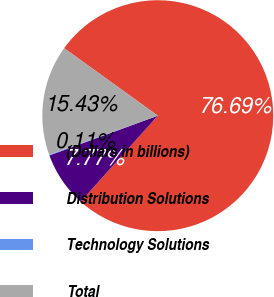Convert chart to OTSL. <chart><loc_0><loc_0><loc_500><loc_500><pie_chart><fcel>(Dollars in billions)<fcel>Distribution Solutions<fcel>Technology Solutions<fcel>Total<nl><fcel>76.69%<fcel>7.77%<fcel>0.11%<fcel>15.43%<nl></chart> 